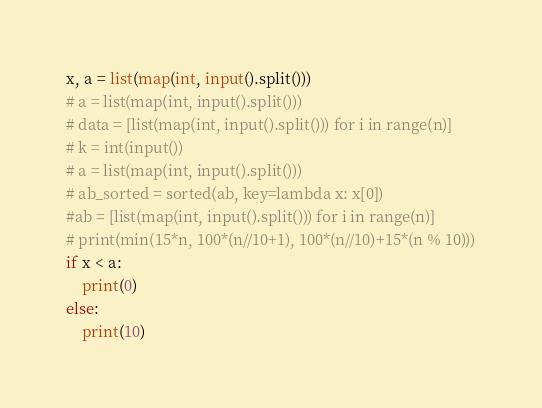<code> <loc_0><loc_0><loc_500><loc_500><_Python_>x, a = list(map(int, input().split()))
# a = list(map(int, input().split()))
# data = [list(map(int, input().split())) for i in range(n)]
# k = int(input())
# a = list(map(int, input().split()))
# ab_sorted = sorted(ab, key=lambda x: x[0])
#ab = [list(map(int, input().split())) for i in range(n)]
# print(min(15*n, 100*(n//10+1), 100*(n//10)+15*(n % 10)))
if x < a:
    print(0)
else:
    print(10)
</code> 